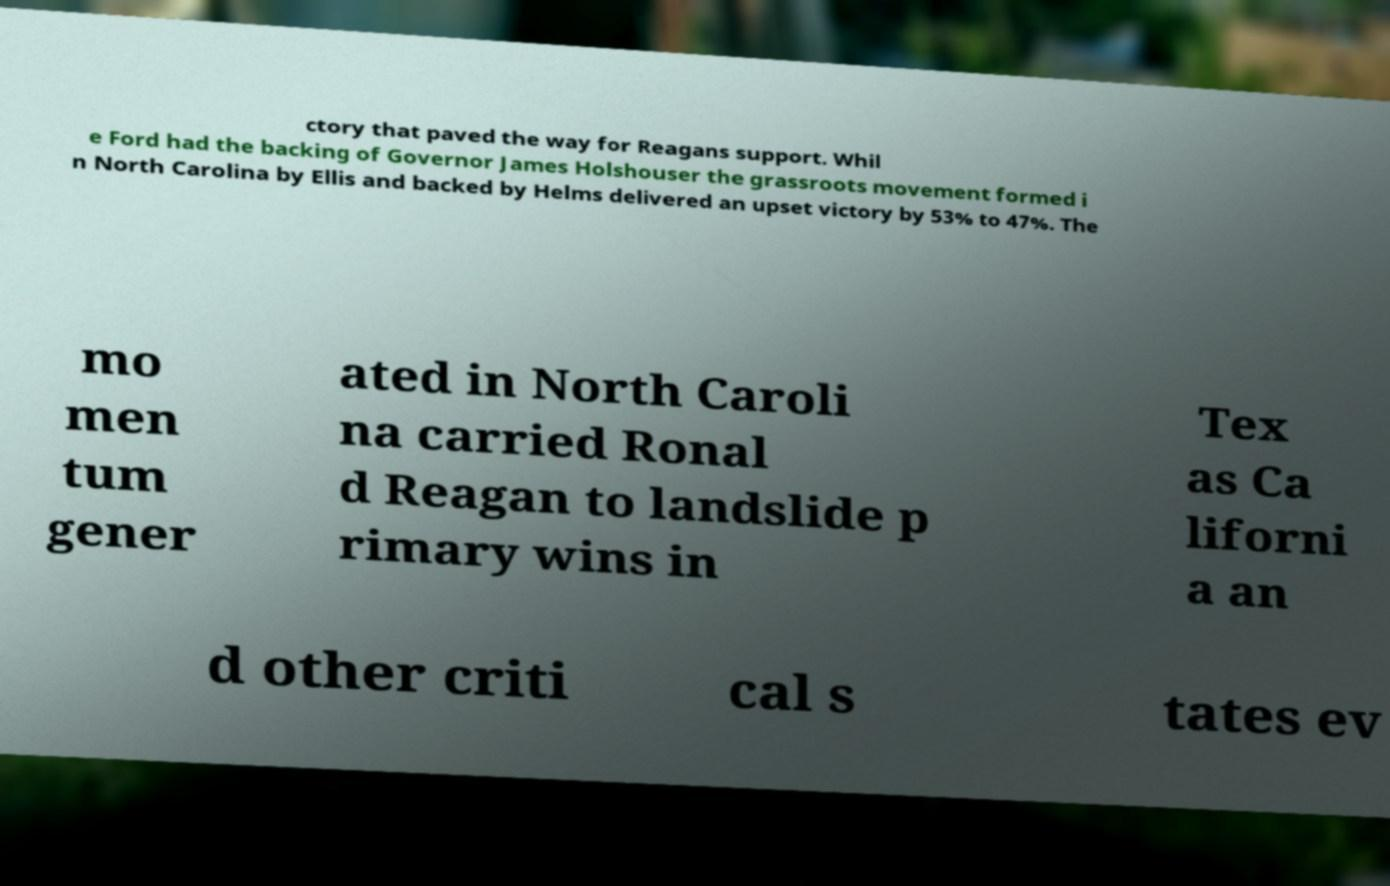For documentation purposes, I need the text within this image transcribed. Could you provide that? ctory that paved the way for Reagans support. Whil e Ford had the backing of Governor James Holshouser the grassroots movement formed i n North Carolina by Ellis and backed by Helms delivered an upset victory by 53% to 47%. The mo men tum gener ated in North Caroli na carried Ronal d Reagan to landslide p rimary wins in Tex as Ca liforni a an d other criti cal s tates ev 